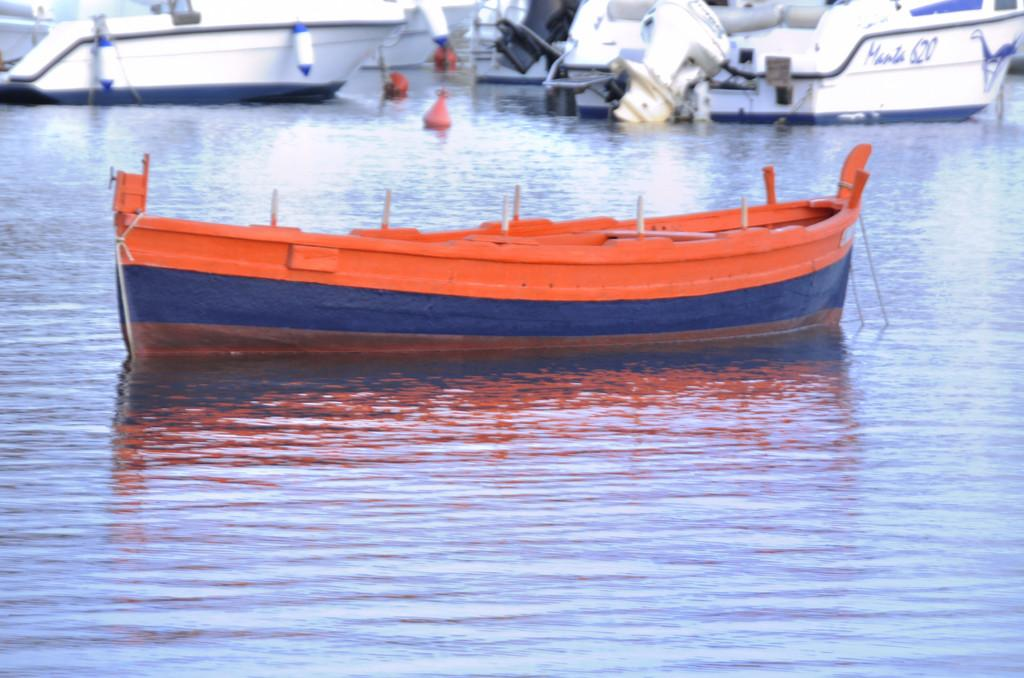<image>
Share a concise interpretation of the image provided. Boats in the harbor and one reads Manta 620 on its rear 